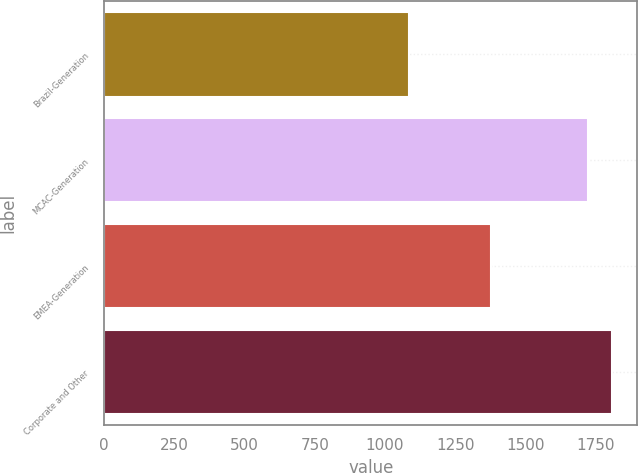Convert chart to OTSL. <chart><loc_0><loc_0><loc_500><loc_500><bar_chart><fcel>Brazil-Generation<fcel>MCAC-Generation<fcel>EMEA-Generation<fcel>Corporate and Other<nl><fcel>1087<fcel>1723<fcel>1376<fcel>1809<nl></chart> 